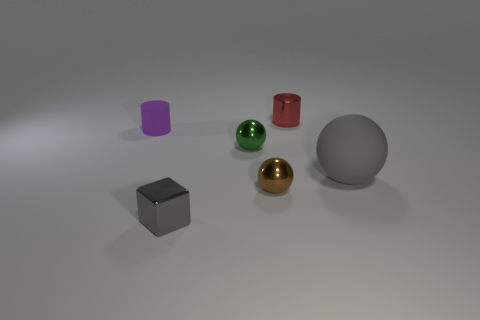Subtract all tiny metallic spheres. How many spheres are left? 1 Add 1 tiny shiny cubes. How many objects exist? 7 Subtract all cubes. How many objects are left? 5 Add 3 small brown metallic objects. How many small brown metallic objects are left? 4 Add 1 tiny gray shiny blocks. How many tiny gray shiny blocks exist? 2 Subtract 0 purple balls. How many objects are left? 6 Subtract all red metal balls. Subtract all metal cylinders. How many objects are left? 5 